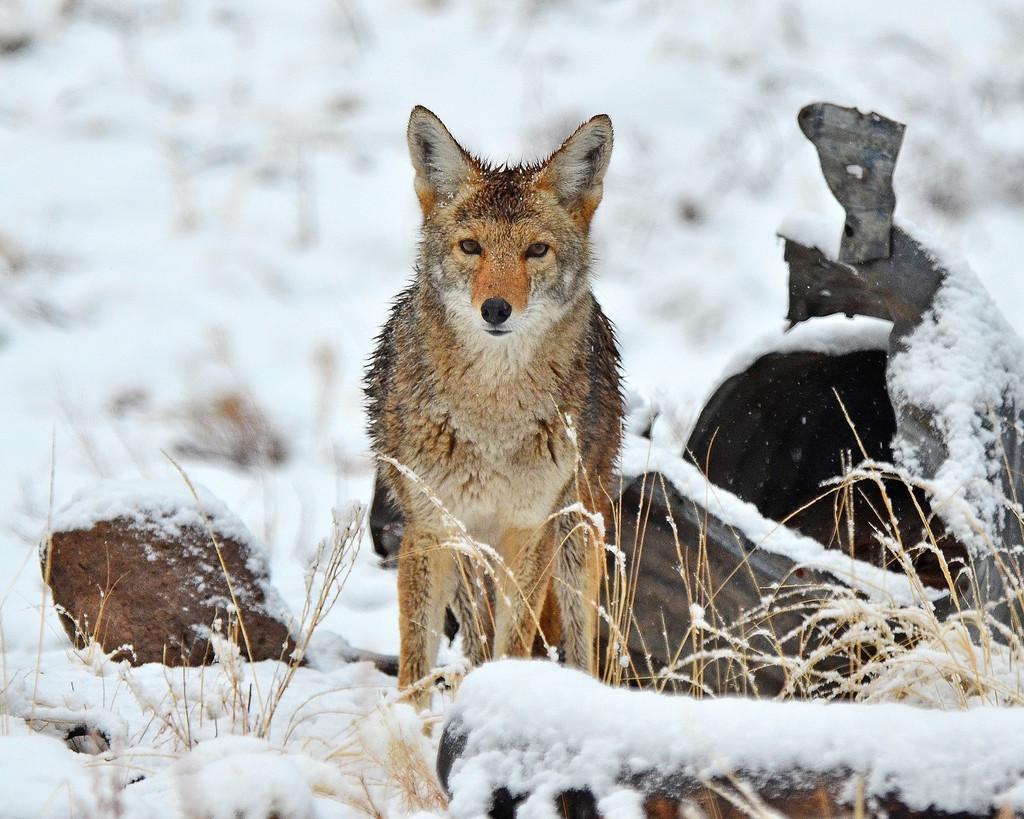How would you summarize this image in a sentence or two? In this image we can see there is a dog standing on the surface of the dog, beside the dog there are some wooden bricks. 